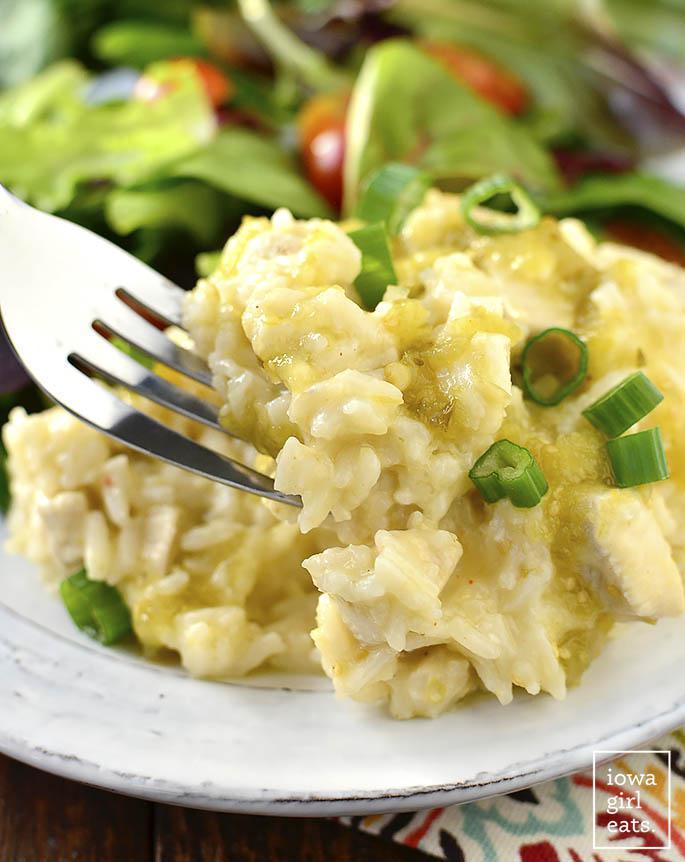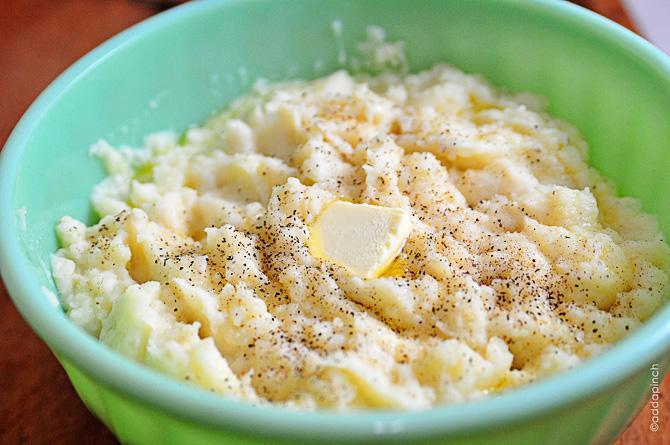The first image is the image on the left, the second image is the image on the right. Considering the images on both sides, is "The food in the image on the right  is in a green bowl." valid? Answer yes or no. Yes. 